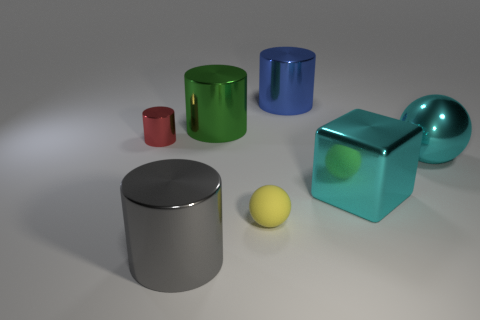Add 2 big cyan metal spheres. How many objects exist? 9 Subtract all balls. How many objects are left? 5 Add 5 yellow objects. How many yellow objects are left? 6 Add 4 red objects. How many red objects exist? 5 Subtract 0 blue spheres. How many objects are left? 7 Subtract all tiny brown metallic blocks. Subtract all red cylinders. How many objects are left? 6 